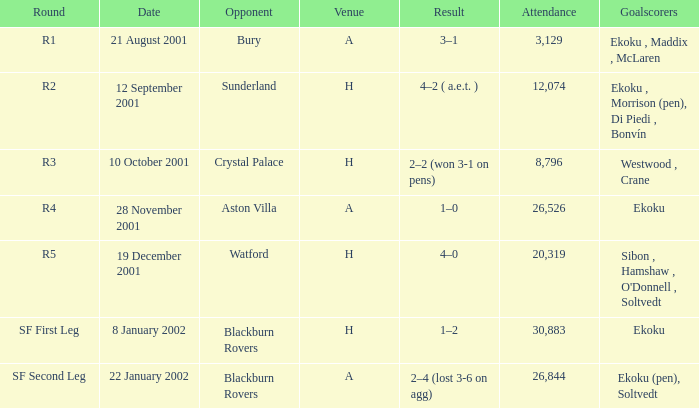Which location has a capacity of more than 26,526 and hosts the first leg round of sf? H. 